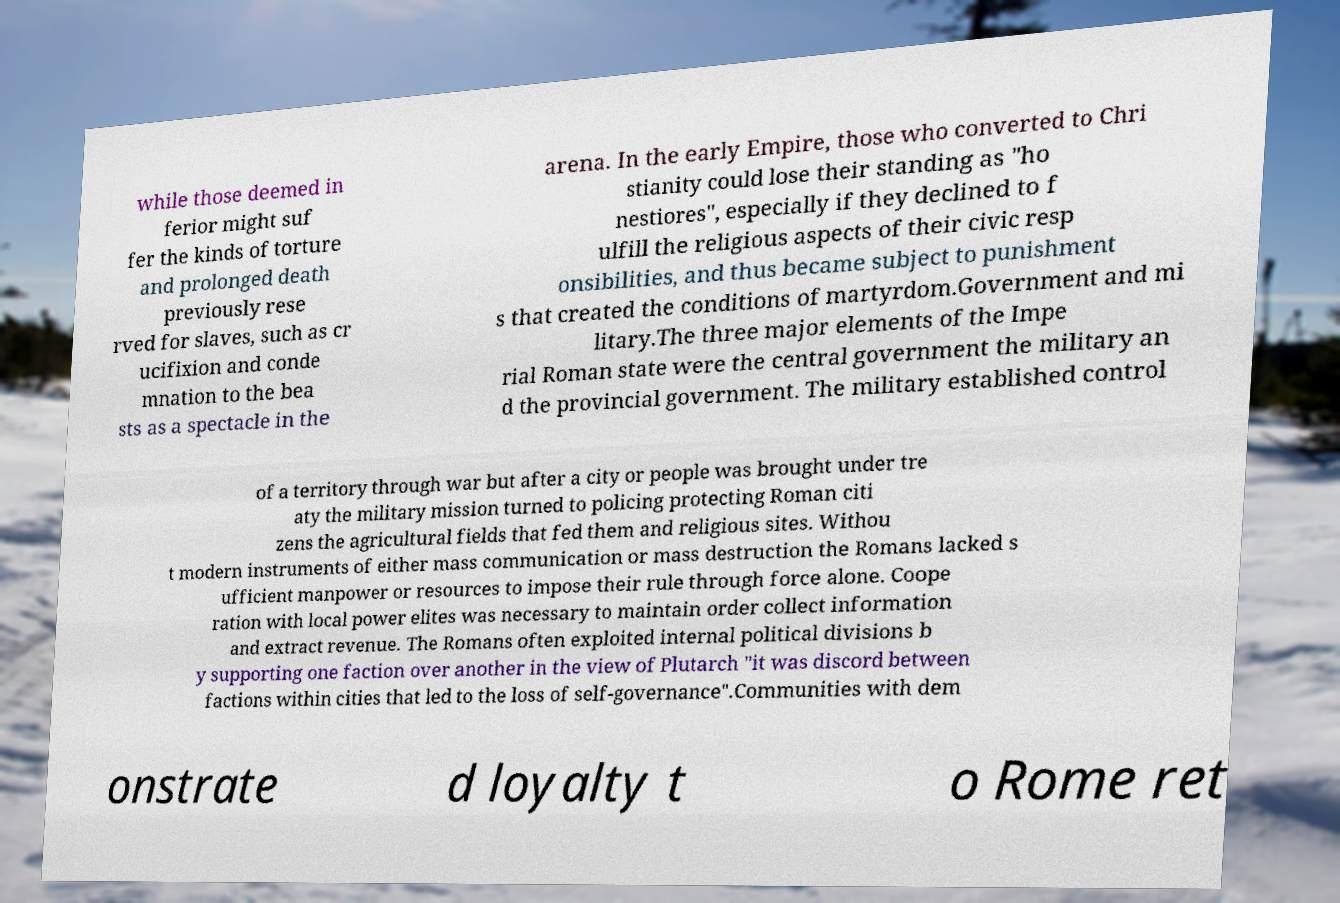Can you read and provide the text displayed in the image?This photo seems to have some interesting text. Can you extract and type it out for me? while those deemed in ferior might suf fer the kinds of torture and prolonged death previously rese rved for slaves, such as cr ucifixion and conde mnation to the bea sts as a spectacle in the arena. In the early Empire, those who converted to Chri stianity could lose their standing as "ho nestiores", especially if they declined to f ulfill the religious aspects of their civic resp onsibilities, and thus became subject to punishment s that created the conditions of martyrdom.Government and mi litary.The three major elements of the Impe rial Roman state were the central government the military an d the provincial government. The military established control of a territory through war but after a city or people was brought under tre aty the military mission turned to policing protecting Roman citi zens the agricultural fields that fed them and religious sites. Withou t modern instruments of either mass communication or mass destruction the Romans lacked s ufficient manpower or resources to impose their rule through force alone. Coope ration with local power elites was necessary to maintain order collect information and extract revenue. The Romans often exploited internal political divisions b y supporting one faction over another in the view of Plutarch "it was discord between factions within cities that led to the loss of self-governance".Communities with dem onstrate d loyalty t o Rome ret 